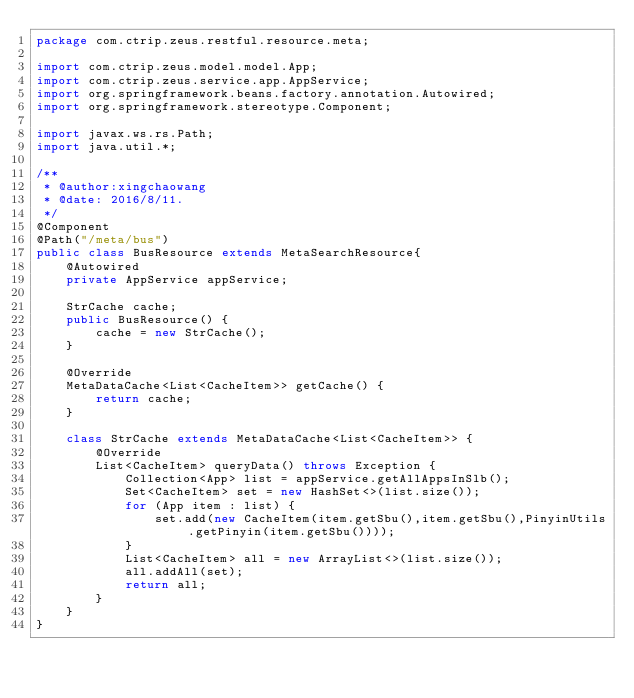Convert code to text. <code><loc_0><loc_0><loc_500><loc_500><_Java_>package com.ctrip.zeus.restful.resource.meta;

import com.ctrip.zeus.model.model.App;
import com.ctrip.zeus.service.app.AppService;
import org.springframework.beans.factory.annotation.Autowired;
import org.springframework.stereotype.Component;

import javax.ws.rs.Path;
import java.util.*;

/**
 * @author:xingchaowang
 * @date: 2016/8/11.
 */
@Component
@Path("/meta/bus")
public class BusResource extends MetaSearchResource{
    @Autowired
    private AppService appService;

    StrCache cache;
    public BusResource() {
        cache = new StrCache();
    }

    @Override
    MetaDataCache<List<CacheItem>> getCache() {
        return cache;
    }

    class StrCache extends MetaDataCache<List<CacheItem>> {
        @Override
        List<CacheItem> queryData() throws Exception {
            Collection<App> list = appService.getAllAppsInSlb();
            Set<CacheItem> set = new HashSet<>(list.size());
            for (App item : list) {
                set.add(new CacheItem(item.getSbu(),item.getSbu(),PinyinUtils.getPinyin(item.getSbu())));
            }
            List<CacheItem> all = new ArrayList<>(list.size());
            all.addAll(set);
            return all;
        }
    }
}
</code> 